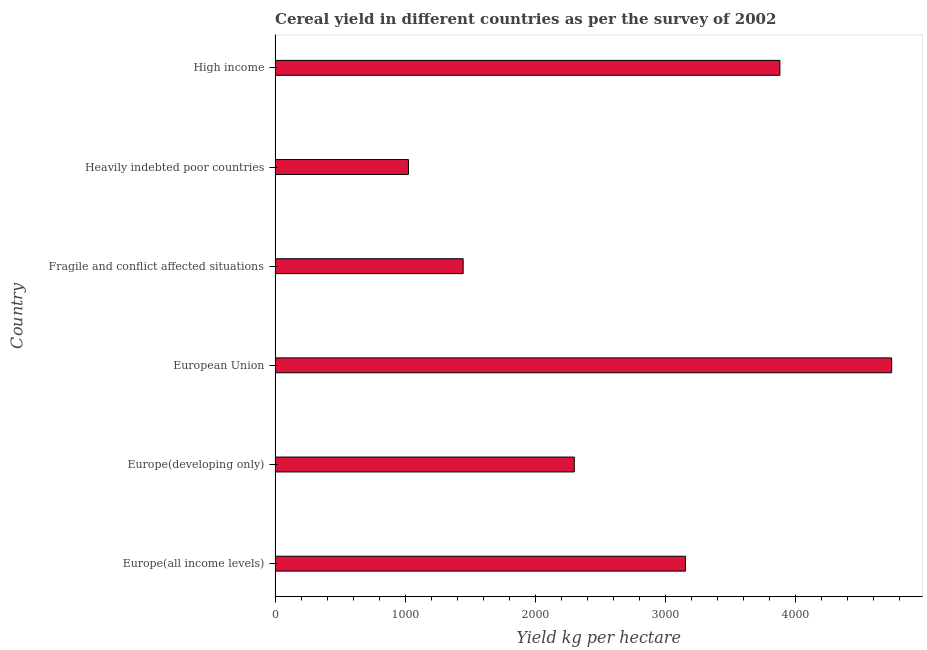Does the graph contain any zero values?
Provide a short and direct response. No. What is the title of the graph?
Offer a very short reply. Cereal yield in different countries as per the survey of 2002. What is the label or title of the X-axis?
Ensure brevity in your answer.  Yield kg per hectare. What is the cereal yield in Europe(developing only)?
Your answer should be very brief. 2300.13. Across all countries, what is the maximum cereal yield?
Provide a short and direct response. 4739.95. Across all countries, what is the minimum cereal yield?
Provide a succinct answer. 1025.22. In which country was the cereal yield maximum?
Offer a very short reply. European Union. In which country was the cereal yield minimum?
Offer a terse response. Heavily indebted poor countries. What is the sum of the cereal yield?
Provide a short and direct response. 1.65e+04. What is the difference between the cereal yield in European Union and Fragile and conflict affected situations?
Keep it short and to the point. 3294.16. What is the average cereal yield per country?
Provide a short and direct response. 2757.75. What is the median cereal yield?
Offer a terse response. 2727.36. In how many countries, is the cereal yield greater than 2400 kg per hectare?
Make the answer very short. 3. What is the ratio of the cereal yield in Heavily indebted poor countries to that in High income?
Your response must be concise. 0.26. Is the cereal yield in European Union less than that in Fragile and conflict affected situations?
Keep it short and to the point. No. What is the difference between the highest and the second highest cereal yield?
Provide a short and direct response. 859.18. Is the sum of the cereal yield in Fragile and conflict affected situations and High income greater than the maximum cereal yield across all countries?
Make the answer very short. Yes. What is the difference between the highest and the lowest cereal yield?
Ensure brevity in your answer.  3714.73. In how many countries, is the cereal yield greater than the average cereal yield taken over all countries?
Your answer should be very brief. 3. How many bars are there?
Ensure brevity in your answer.  6. Are all the bars in the graph horizontal?
Ensure brevity in your answer.  Yes. How many countries are there in the graph?
Ensure brevity in your answer.  6. What is the difference between two consecutive major ticks on the X-axis?
Your response must be concise. 1000. What is the Yield kg per hectare of Europe(all income levels)?
Ensure brevity in your answer.  3154.6. What is the Yield kg per hectare of Europe(developing only)?
Give a very brief answer. 2300.13. What is the Yield kg per hectare of European Union?
Your answer should be compact. 4739.95. What is the Yield kg per hectare of Fragile and conflict affected situations?
Make the answer very short. 1445.8. What is the Yield kg per hectare of Heavily indebted poor countries?
Offer a very short reply. 1025.22. What is the Yield kg per hectare in High income?
Make the answer very short. 3880.78. What is the difference between the Yield kg per hectare in Europe(all income levels) and Europe(developing only)?
Keep it short and to the point. 854.48. What is the difference between the Yield kg per hectare in Europe(all income levels) and European Union?
Give a very brief answer. -1585.35. What is the difference between the Yield kg per hectare in Europe(all income levels) and Fragile and conflict affected situations?
Offer a terse response. 1708.8. What is the difference between the Yield kg per hectare in Europe(all income levels) and Heavily indebted poor countries?
Ensure brevity in your answer.  2129.38. What is the difference between the Yield kg per hectare in Europe(all income levels) and High income?
Offer a very short reply. -726.17. What is the difference between the Yield kg per hectare in Europe(developing only) and European Union?
Provide a short and direct response. -2439.83. What is the difference between the Yield kg per hectare in Europe(developing only) and Fragile and conflict affected situations?
Your answer should be very brief. 854.33. What is the difference between the Yield kg per hectare in Europe(developing only) and Heavily indebted poor countries?
Offer a very short reply. 1274.9. What is the difference between the Yield kg per hectare in Europe(developing only) and High income?
Your response must be concise. -1580.65. What is the difference between the Yield kg per hectare in European Union and Fragile and conflict affected situations?
Ensure brevity in your answer.  3294.15. What is the difference between the Yield kg per hectare in European Union and Heavily indebted poor countries?
Offer a very short reply. 3714.73. What is the difference between the Yield kg per hectare in European Union and High income?
Offer a very short reply. 859.18. What is the difference between the Yield kg per hectare in Fragile and conflict affected situations and Heavily indebted poor countries?
Your response must be concise. 420.58. What is the difference between the Yield kg per hectare in Fragile and conflict affected situations and High income?
Your answer should be compact. -2434.98. What is the difference between the Yield kg per hectare in Heavily indebted poor countries and High income?
Give a very brief answer. -2855.55. What is the ratio of the Yield kg per hectare in Europe(all income levels) to that in Europe(developing only)?
Give a very brief answer. 1.37. What is the ratio of the Yield kg per hectare in Europe(all income levels) to that in European Union?
Your answer should be very brief. 0.67. What is the ratio of the Yield kg per hectare in Europe(all income levels) to that in Fragile and conflict affected situations?
Ensure brevity in your answer.  2.18. What is the ratio of the Yield kg per hectare in Europe(all income levels) to that in Heavily indebted poor countries?
Make the answer very short. 3.08. What is the ratio of the Yield kg per hectare in Europe(all income levels) to that in High income?
Provide a succinct answer. 0.81. What is the ratio of the Yield kg per hectare in Europe(developing only) to that in European Union?
Make the answer very short. 0.48. What is the ratio of the Yield kg per hectare in Europe(developing only) to that in Fragile and conflict affected situations?
Provide a short and direct response. 1.59. What is the ratio of the Yield kg per hectare in Europe(developing only) to that in Heavily indebted poor countries?
Keep it short and to the point. 2.24. What is the ratio of the Yield kg per hectare in Europe(developing only) to that in High income?
Give a very brief answer. 0.59. What is the ratio of the Yield kg per hectare in European Union to that in Fragile and conflict affected situations?
Give a very brief answer. 3.28. What is the ratio of the Yield kg per hectare in European Union to that in Heavily indebted poor countries?
Your answer should be very brief. 4.62. What is the ratio of the Yield kg per hectare in European Union to that in High income?
Your answer should be very brief. 1.22. What is the ratio of the Yield kg per hectare in Fragile and conflict affected situations to that in Heavily indebted poor countries?
Offer a terse response. 1.41. What is the ratio of the Yield kg per hectare in Fragile and conflict affected situations to that in High income?
Your answer should be compact. 0.37. What is the ratio of the Yield kg per hectare in Heavily indebted poor countries to that in High income?
Provide a succinct answer. 0.26. 